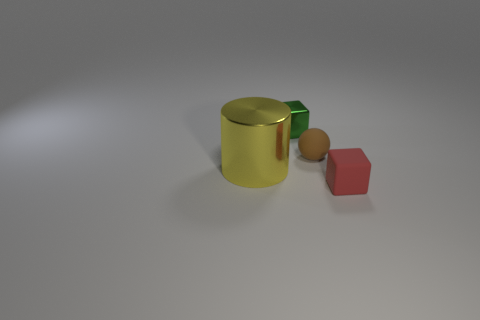Is the number of metallic cubes that are behind the tiny red cube greater than the number of green rubber balls?
Offer a terse response. Yes. What is the shape of the brown object that is made of the same material as the tiny red object?
Provide a succinct answer. Sphere. There is a tiny matte thing behind the small cube that is to the right of the green object; what is its color?
Give a very brief answer. Brown. Is the shape of the green thing the same as the red object?
Your answer should be compact. Yes. There is another thing that is the same shape as the tiny green shiny thing; what is it made of?
Keep it short and to the point. Rubber. Are there any tiny things right of the tiny cube that is behind the small thing that is to the right of the small brown matte thing?
Provide a short and direct response. Yes. There is a red object; is its shape the same as the small shiny object that is behind the large cylinder?
Keep it short and to the point. Yes. Are any small blue spheres visible?
Your answer should be very brief. No. Is there a yellow cylinder made of the same material as the green cube?
Give a very brief answer. Yes. The shiny cylinder has what color?
Make the answer very short. Yellow. 